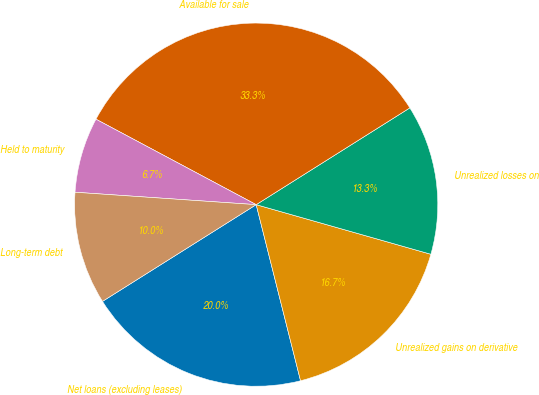Convert chart to OTSL. <chart><loc_0><loc_0><loc_500><loc_500><pie_chart><fcel>Net loans (excluding leases)<fcel>Unrealized gains on derivative<fcel>Unrealized losses on<fcel>Available for sale<fcel>Held to maturity<fcel>Long-term debt<nl><fcel>19.99%<fcel>16.67%<fcel>13.35%<fcel>33.26%<fcel>6.71%<fcel>10.03%<nl></chart> 